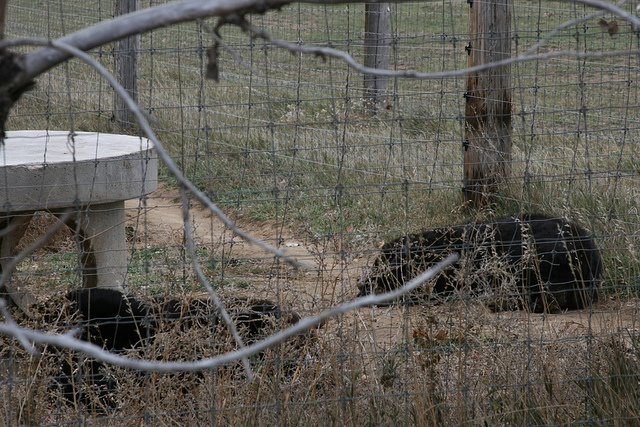Describe the objects in this image and their specific colors. I can see bench in black, gray, lightgray, and darkgray tones, bear in black and gray tones, and bear in black, gray, and darkgray tones in this image. 